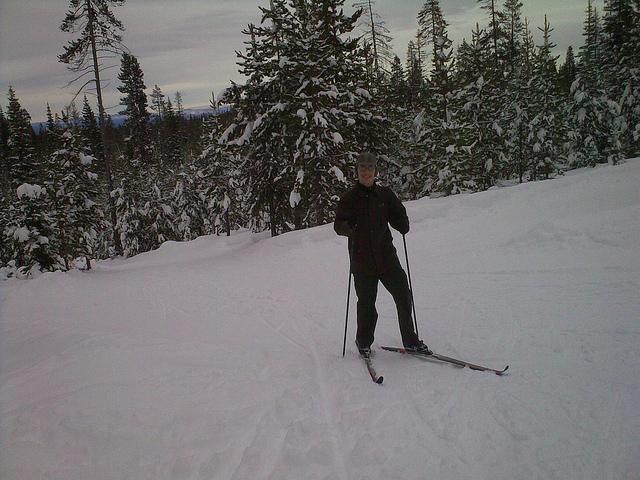What is this person wearing on their face?
Concise answer only. Glasses. Is it winter?
Concise answer only. Yes. How many skateboarders have stopped to take a break?
Quick response, please. 0. What sport is shown?
Give a very brief answer. Skiing. Is the man in the picture wearing skis?
Keep it brief. Yes. Is the man wearing goggles?
Quick response, please. No. Is the skier moving?
Concise answer only. No. What time of the day is it?
Write a very short answer. Dusk. Where are the skis?
Keep it brief. On his feet. Is this person skiing or snowboarding?
Short answer required. Skiing. What color is the jacket?
Keep it brief. Black. What is the person doing?
Answer briefly. Skiing. Is the snow deep?
Keep it brief. No. 